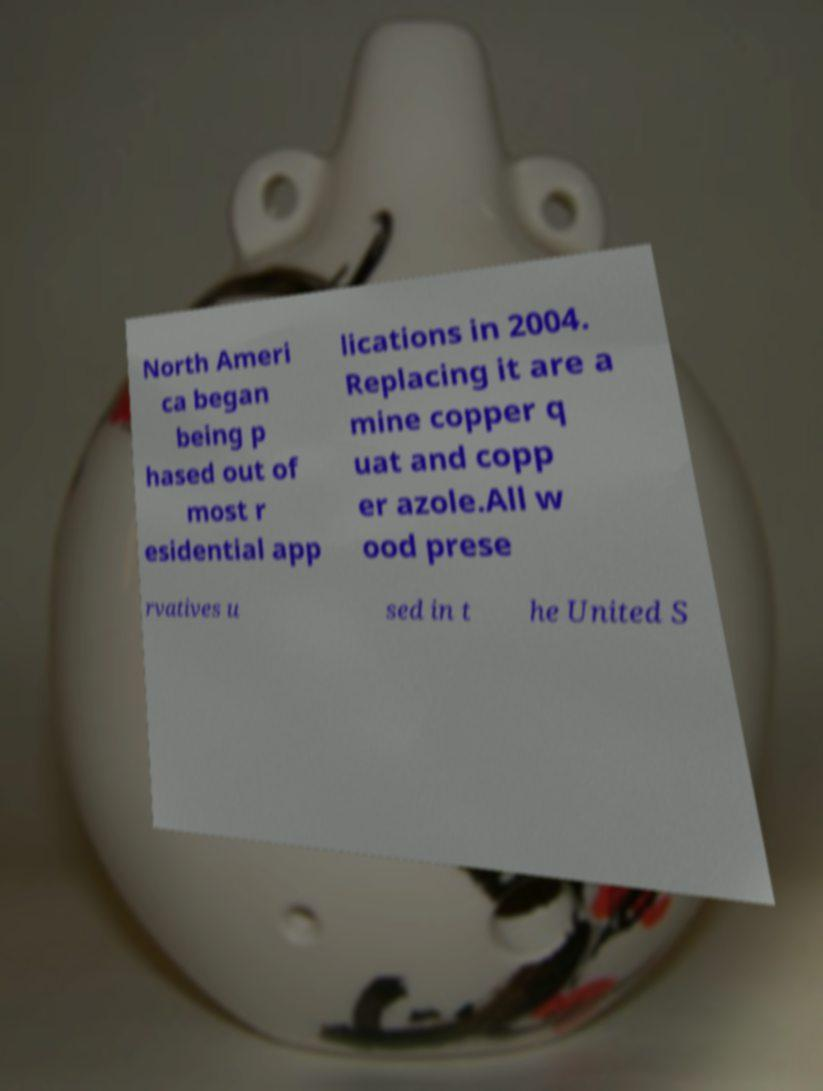Can you accurately transcribe the text from the provided image for me? North Ameri ca began being p hased out of most r esidential app lications in 2004. Replacing it are a mine copper q uat and copp er azole.All w ood prese rvatives u sed in t he United S 